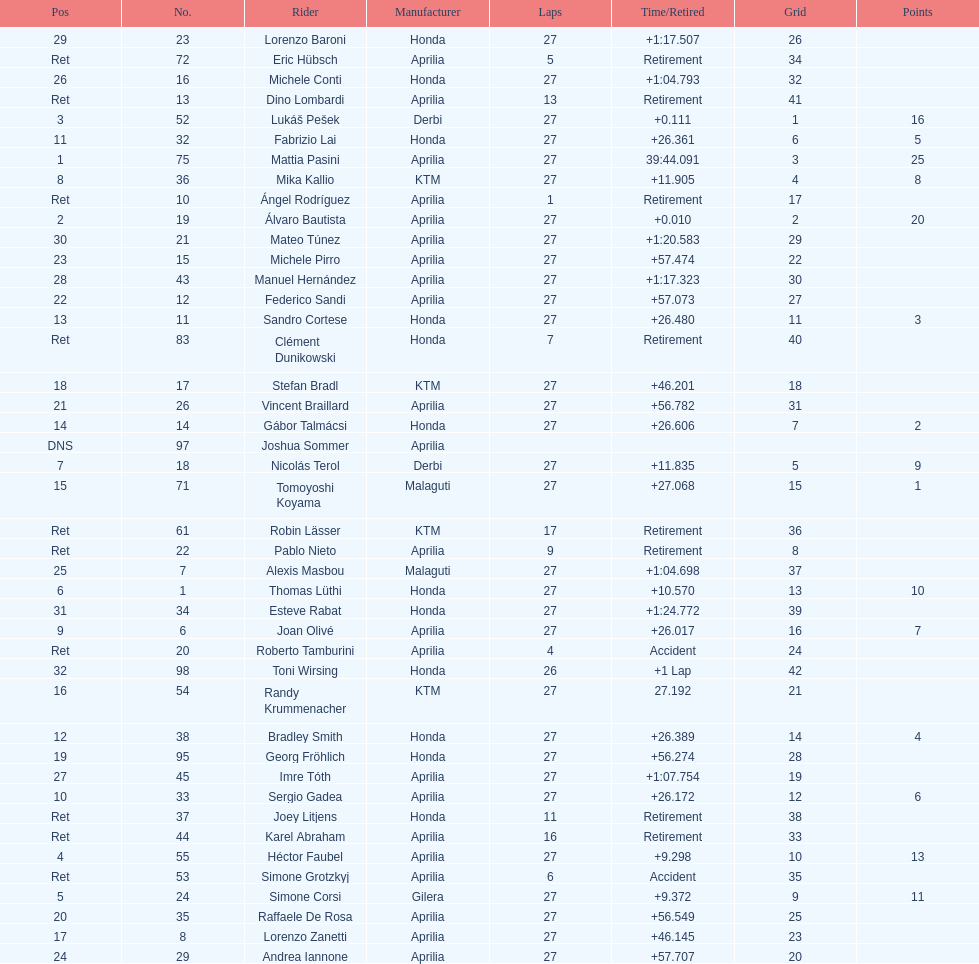Who placed higher, bradl or gadea? Sergio Gadea. 